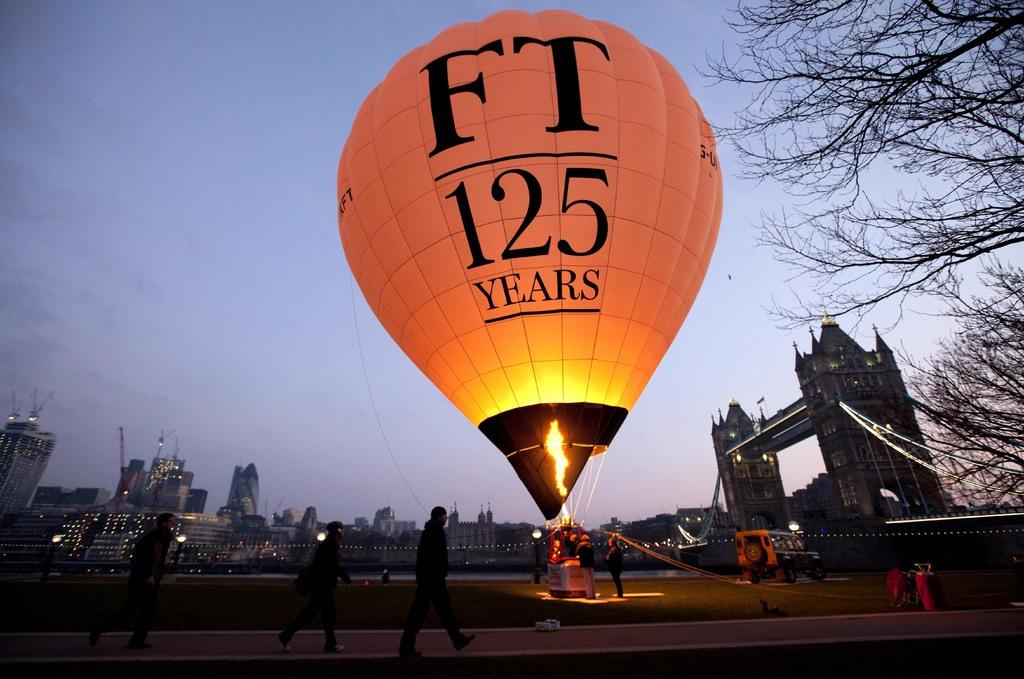<image>
Present a compact description of the photo's key features. A hot air balloon taking off with an FT logo on it. 